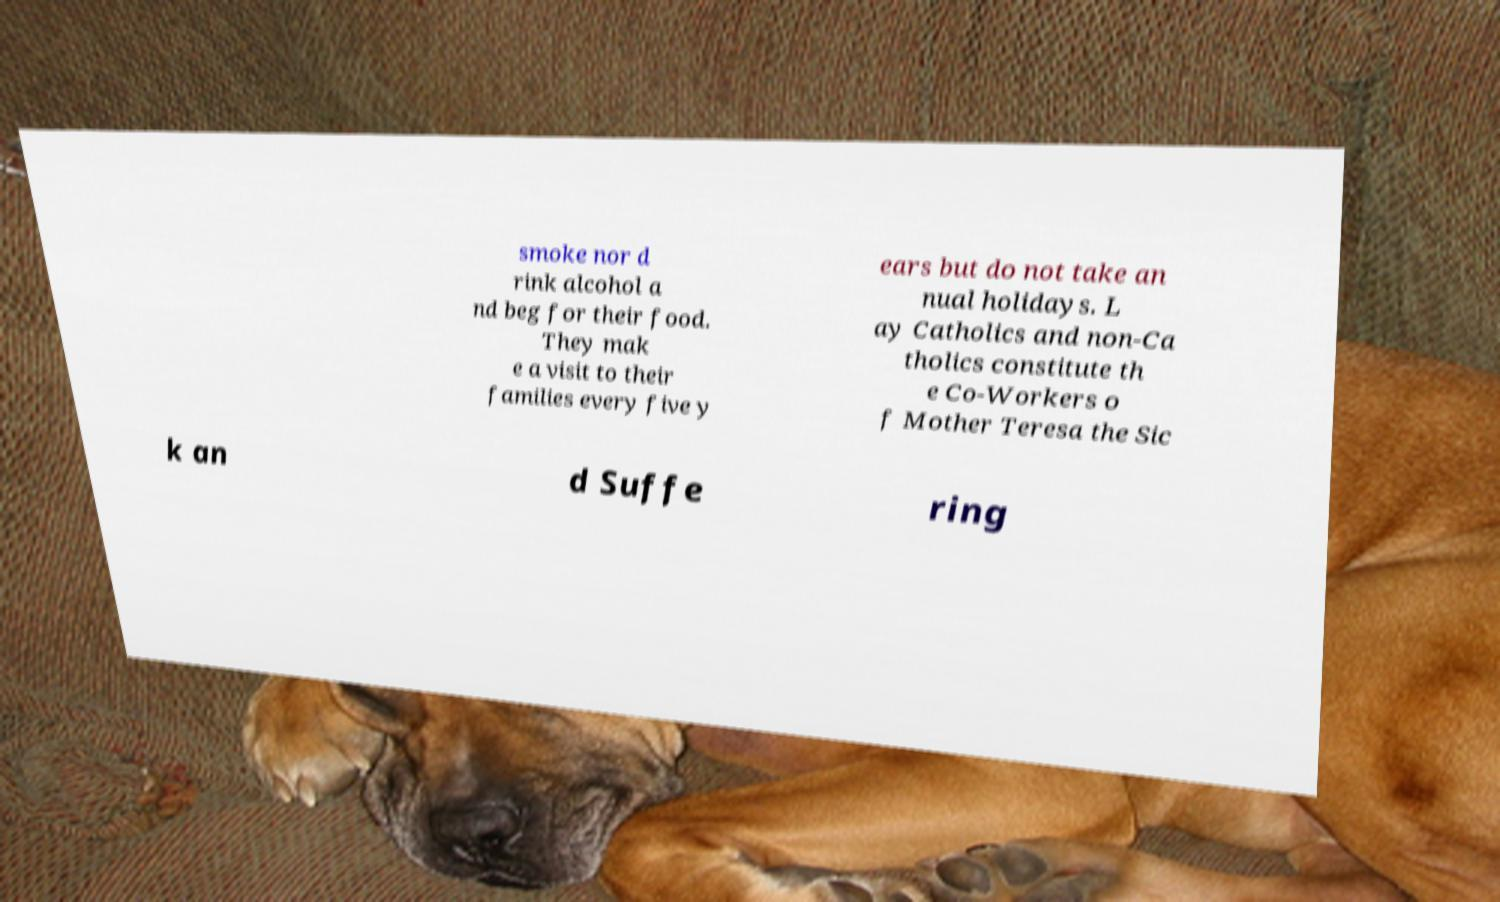Can you read and provide the text displayed in the image?This photo seems to have some interesting text. Can you extract and type it out for me? smoke nor d rink alcohol a nd beg for their food. They mak e a visit to their families every five y ears but do not take an nual holidays. L ay Catholics and non-Ca tholics constitute th e Co-Workers o f Mother Teresa the Sic k an d Suffe ring 